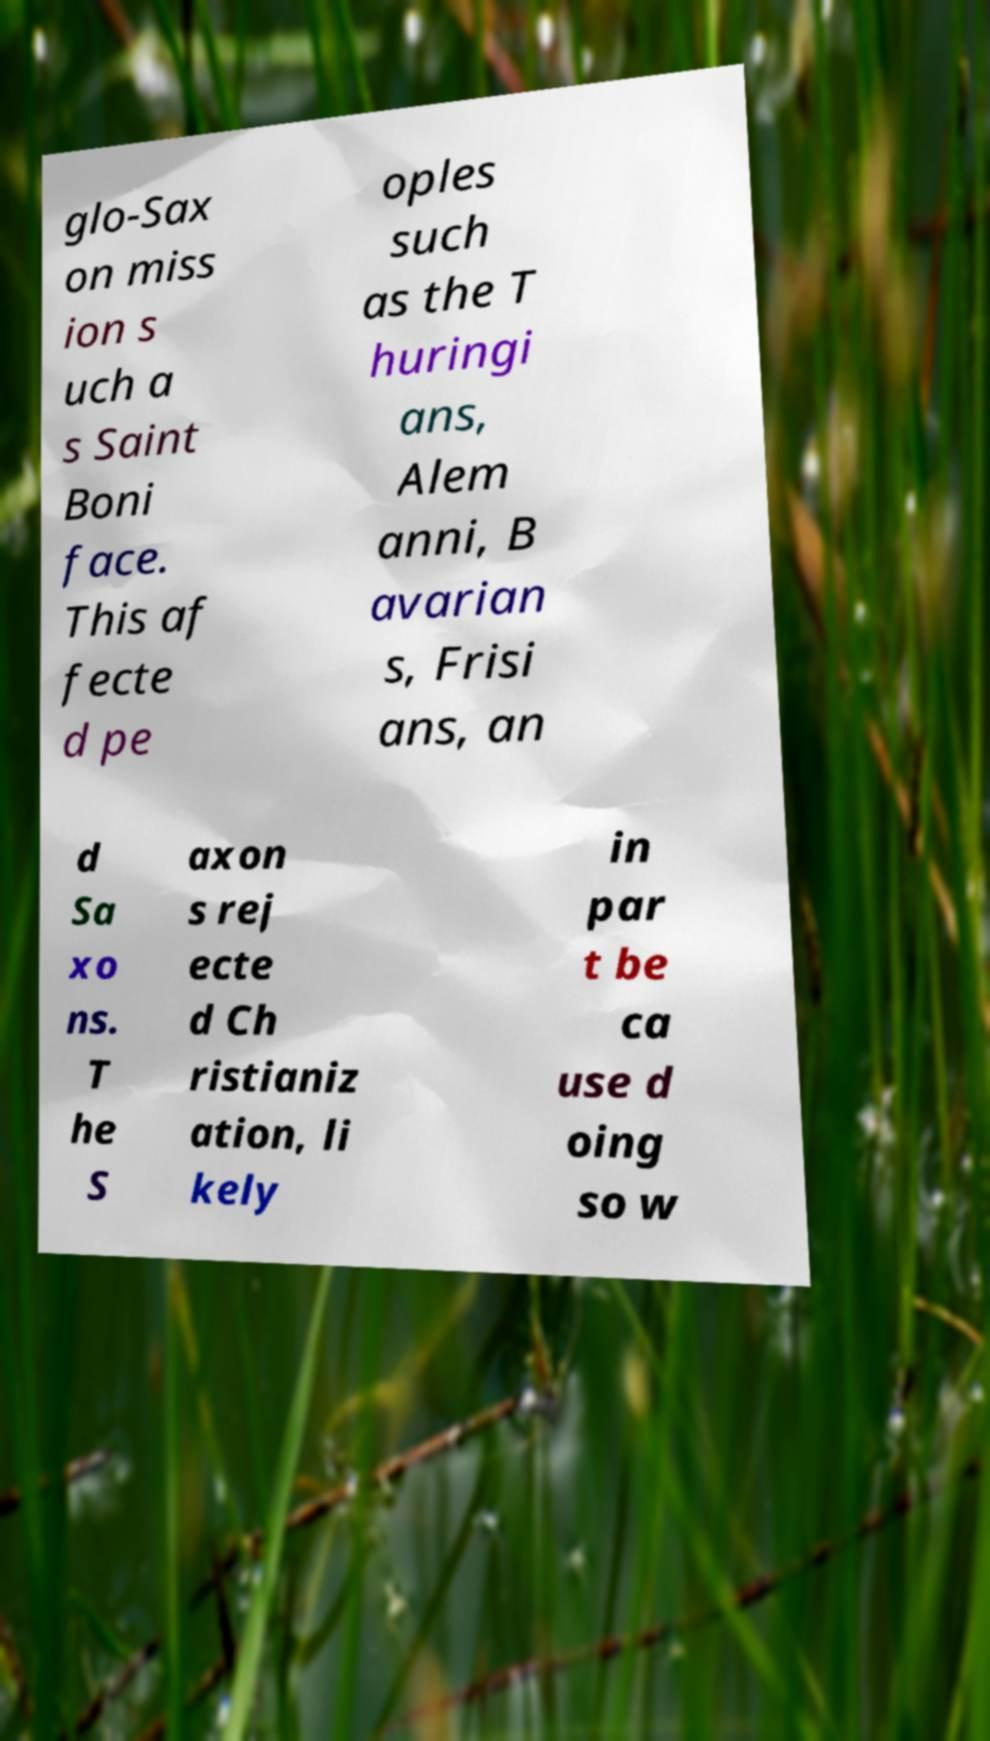Can you accurately transcribe the text from the provided image for me? glo-Sax on miss ion s uch a s Saint Boni face. This af fecte d pe oples such as the T huringi ans, Alem anni, B avarian s, Frisi ans, an d Sa xo ns. T he S axon s rej ecte d Ch ristianiz ation, li kely in par t be ca use d oing so w 